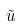<formula> <loc_0><loc_0><loc_500><loc_500>\tilde { u }</formula> 